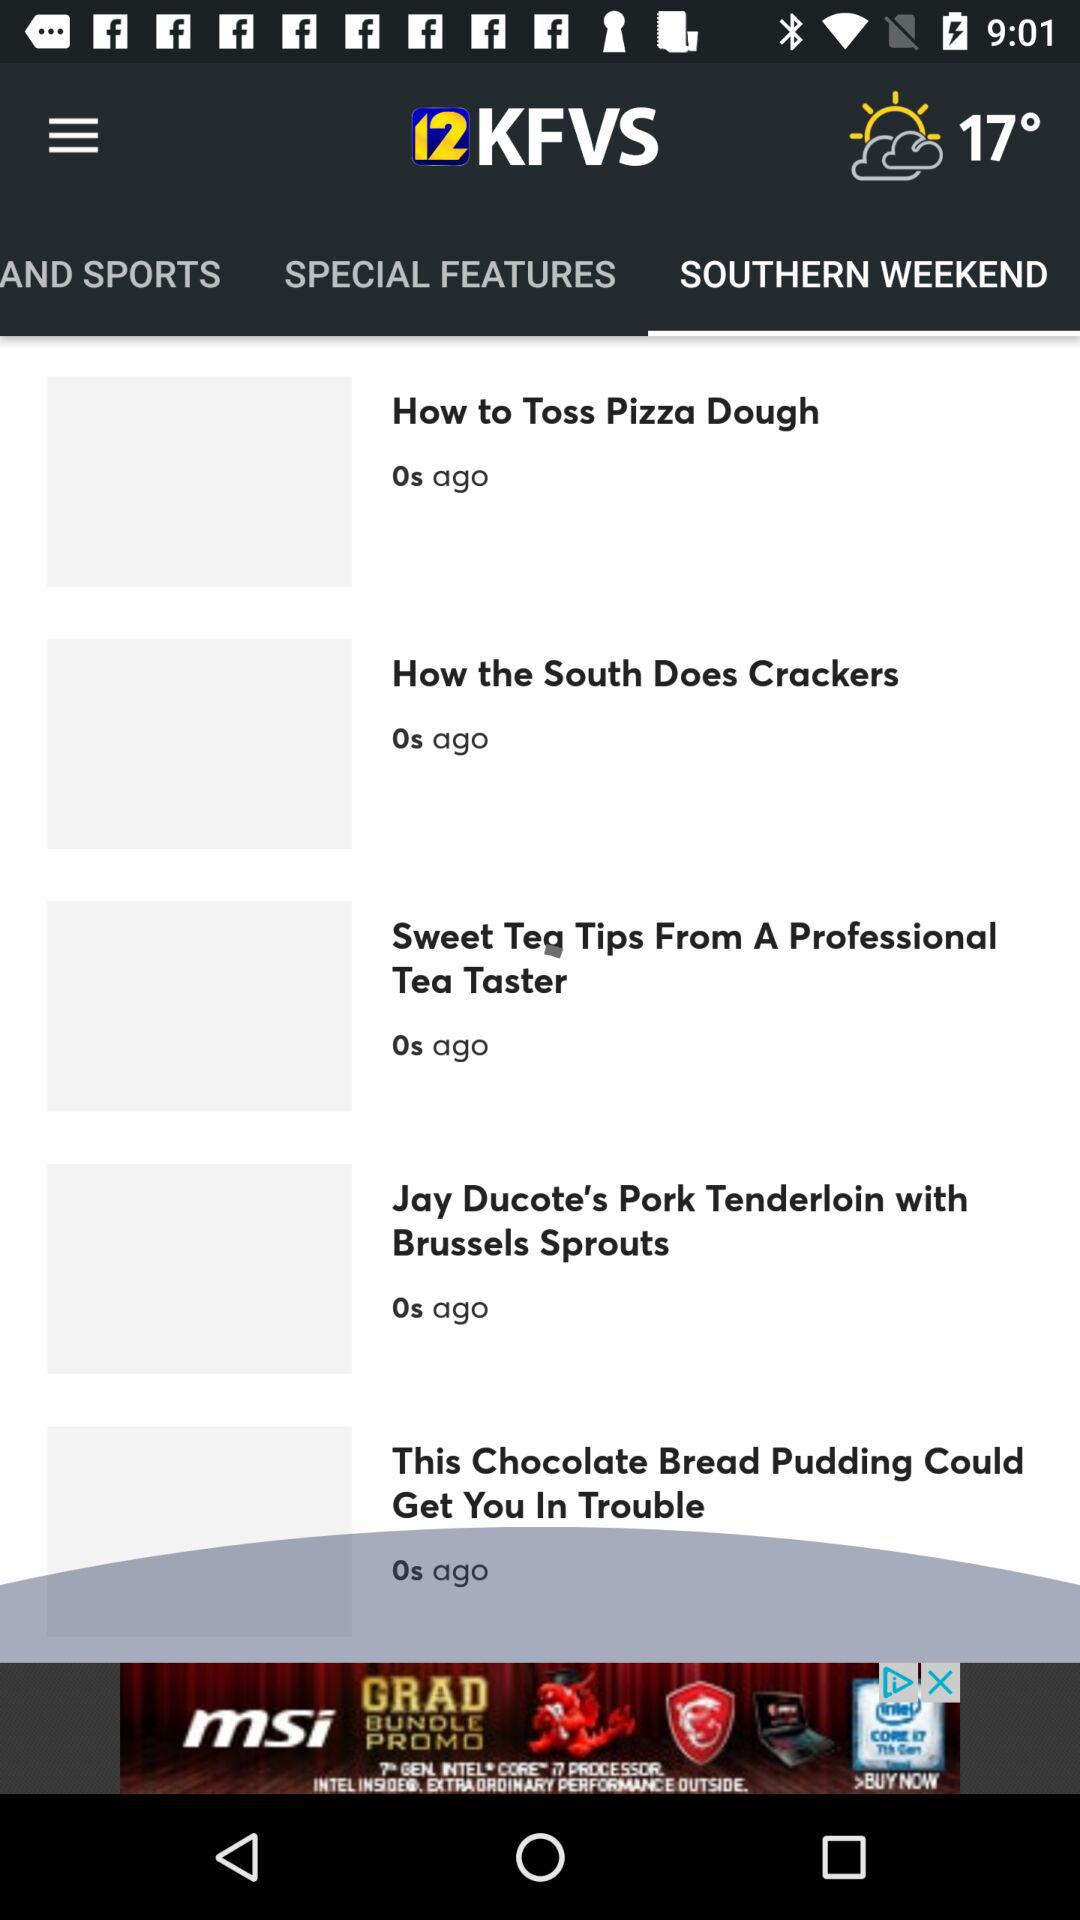Which is the selected tab? The selected tab is "SOUTHERN WEEKEND". 